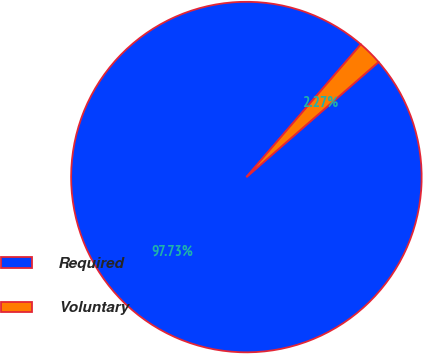<chart> <loc_0><loc_0><loc_500><loc_500><pie_chart><fcel>Required<fcel>Voluntary<nl><fcel>97.73%<fcel>2.27%<nl></chart> 